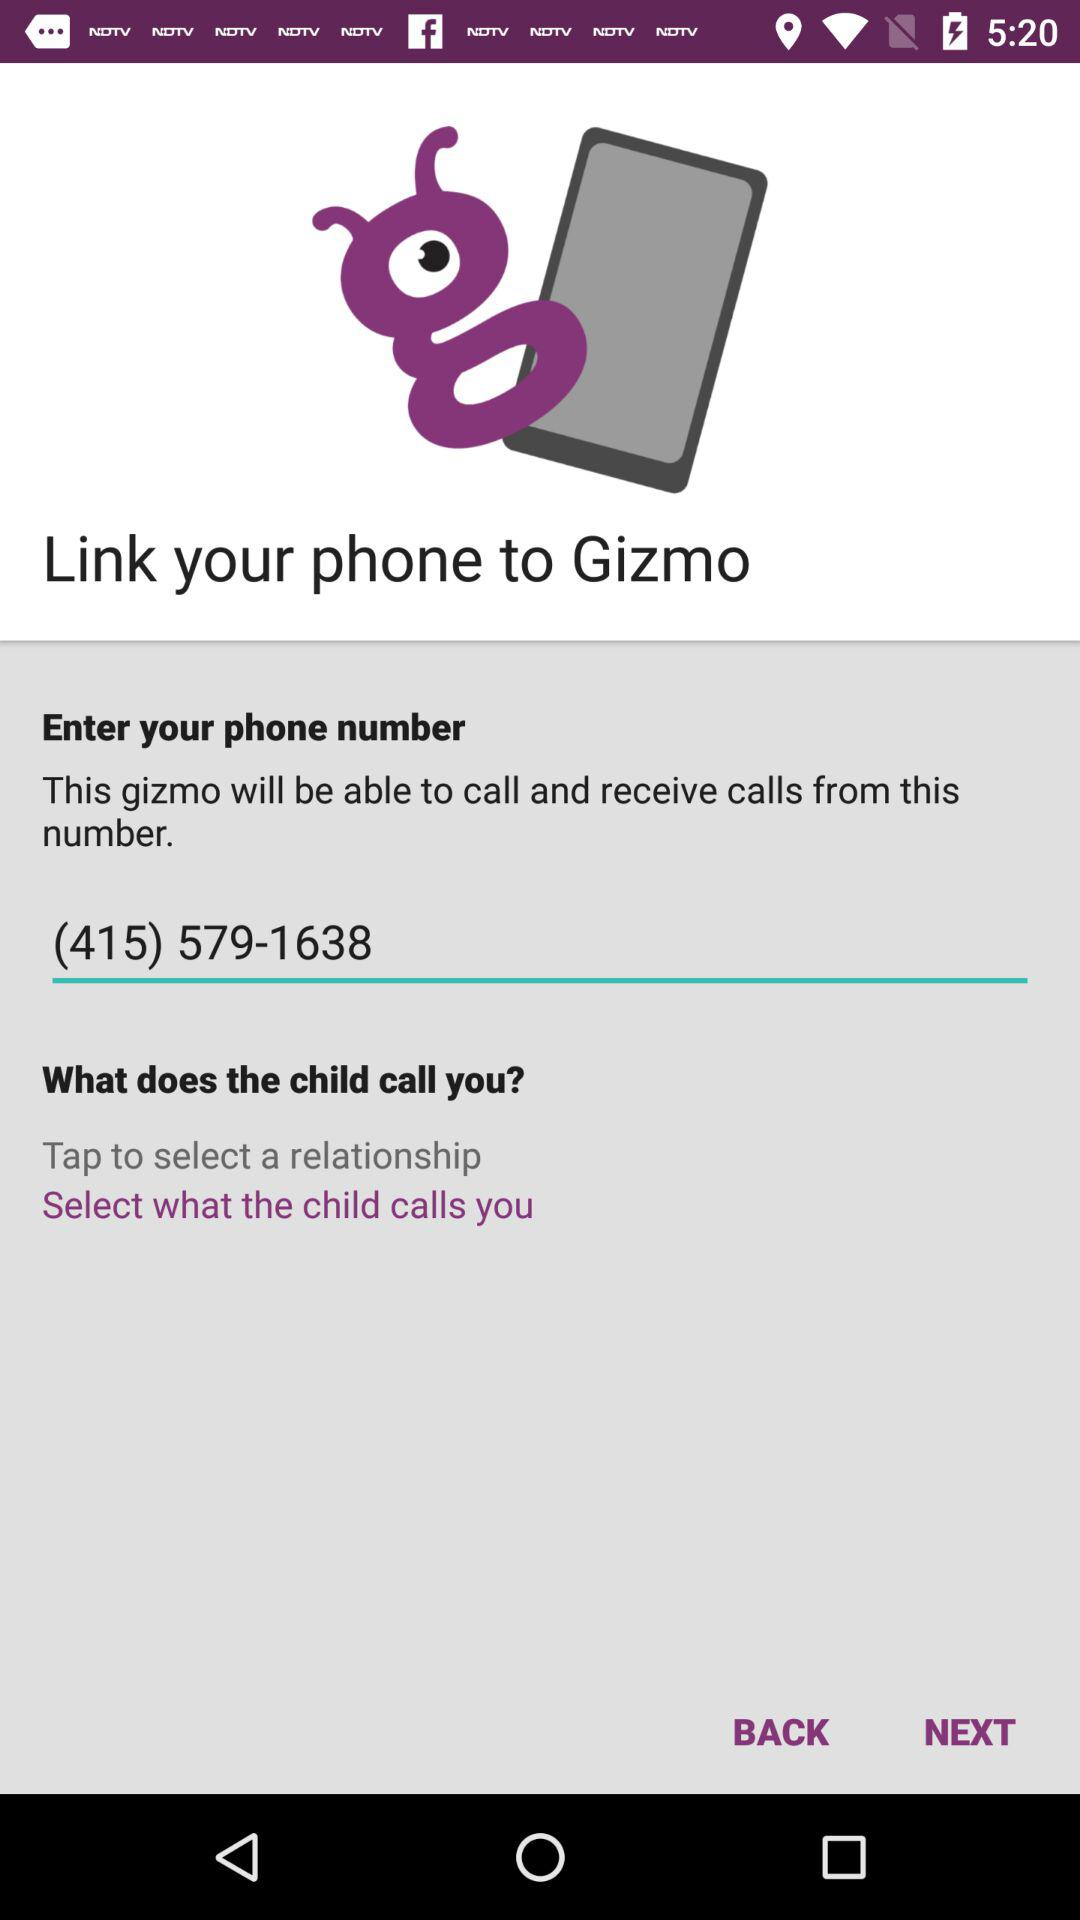How many numbers are in the phone number?
Answer the question using a single word or phrase. 10 